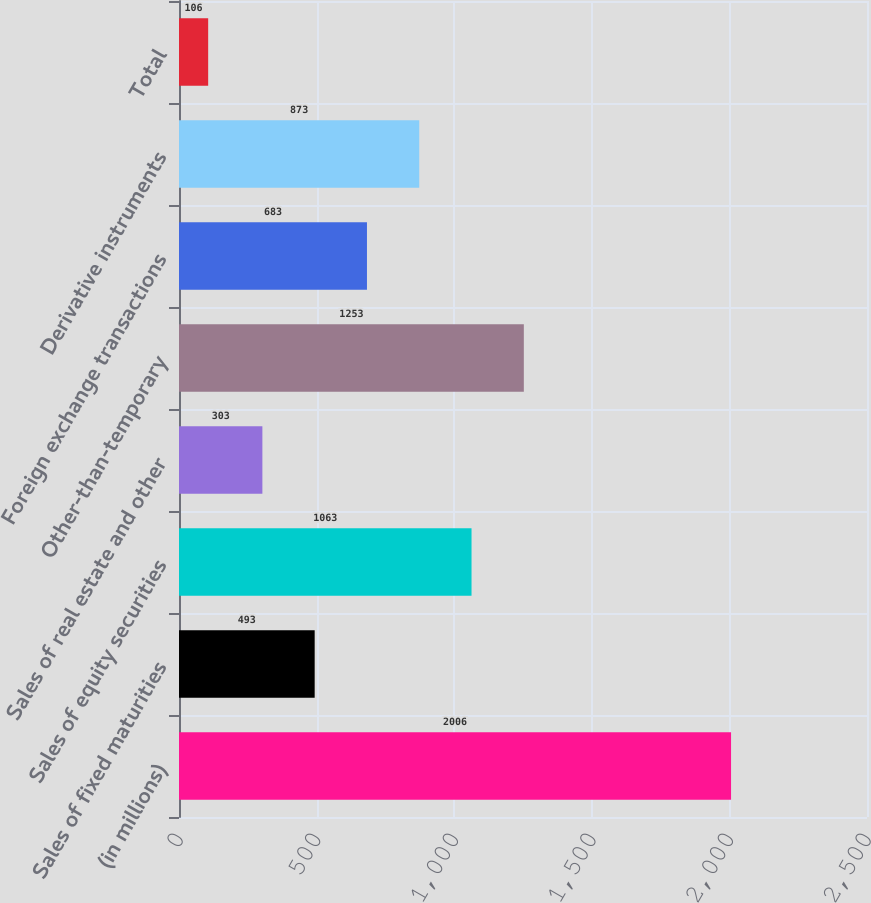Convert chart. <chart><loc_0><loc_0><loc_500><loc_500><bar_chart><fcel>(in millions)<fcel>Sales of fixed maturities<fcel>Sales of equity securities<fcel>Sales of real estate and other<fcel>Other-than-temporary<fcel>Foreign exchange transactions<fcel>Derivative instruments<fcel>Total<nl><fcel>2006<fcel>493<fcel>1063<fcel>303<fcel>1253<fcel>683<fcel>873<fcel>106<nl></chart> 